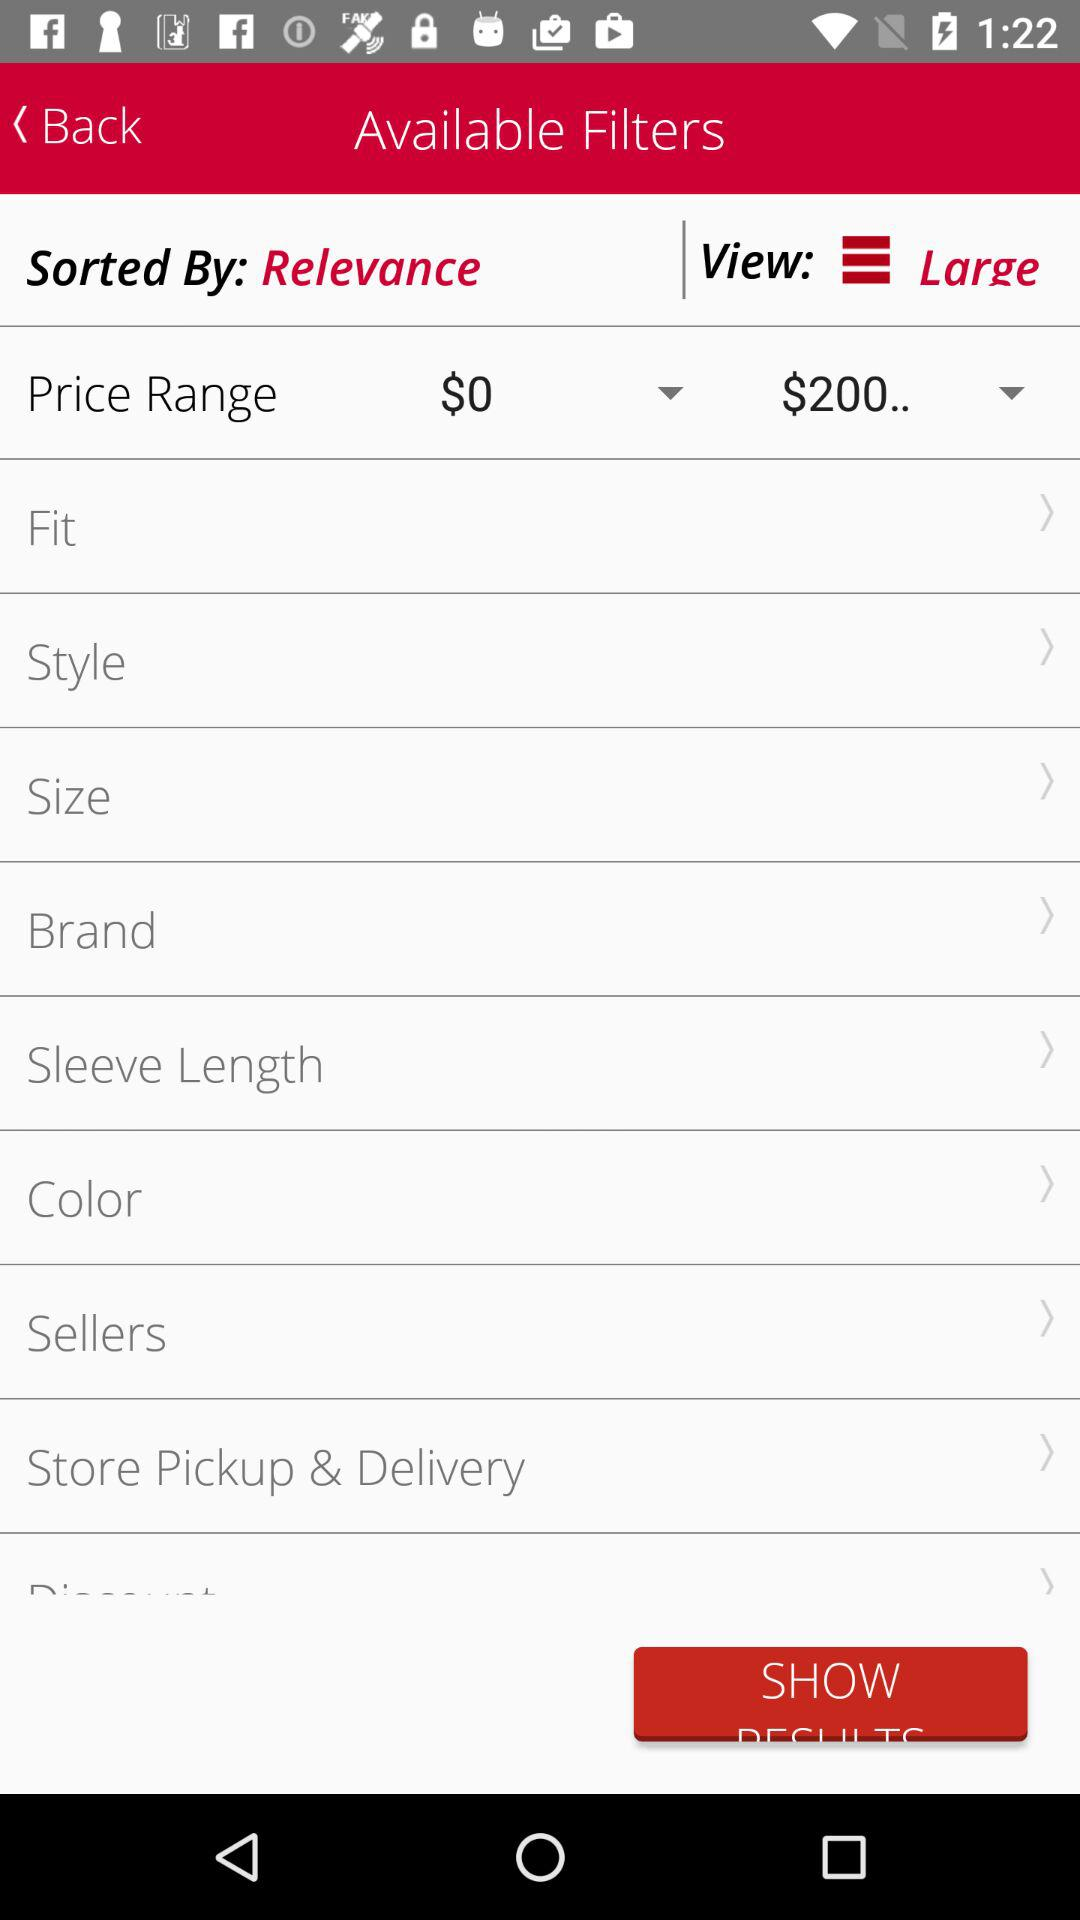What is the selected view size? The selected view size is large. 